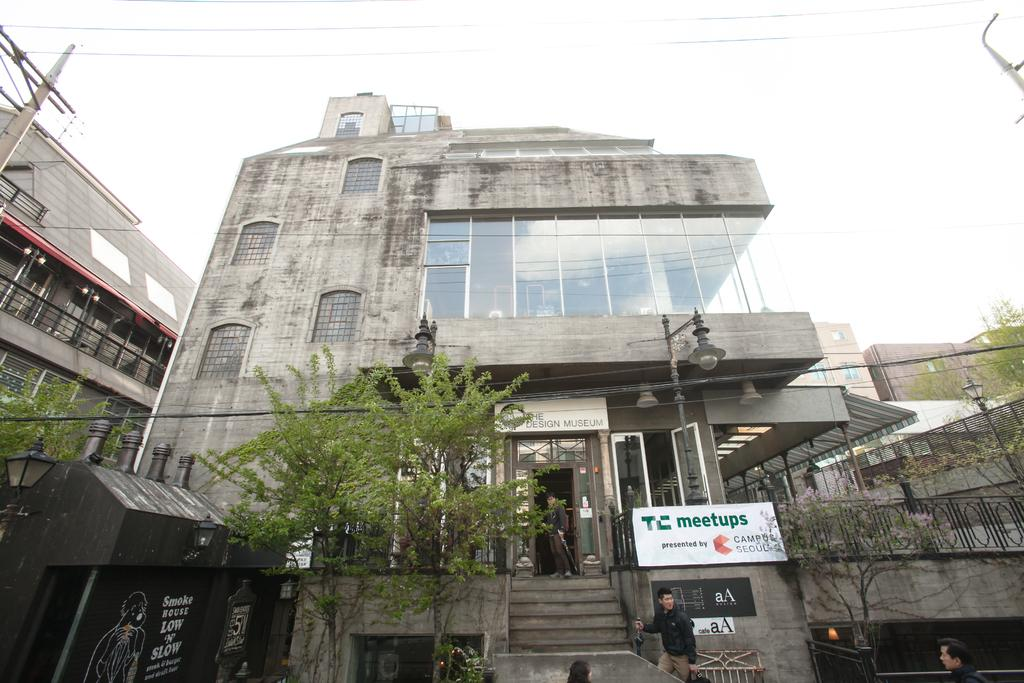What type of structures can be seen in the image? There are buildings in the image. What architectural feature is present in the image? There is railing in the image. What other objects can be seen in the image? There are poles, trees, electric wires, and a board in the image. What is visible in the sky in the image? The sky is visible in the image. Are there any people present in the image? Yes, people are on the stairs of a building in the image. What type of poison is being used by the people on the stairs in the image? There is no poison present in the image; people are simply on the stairs of a building. What achievement has the person holding the copper trophy in the image accomplished? There is no person holding a copper trophy in the image; the provided facts do not mention any trophies or achievements. 